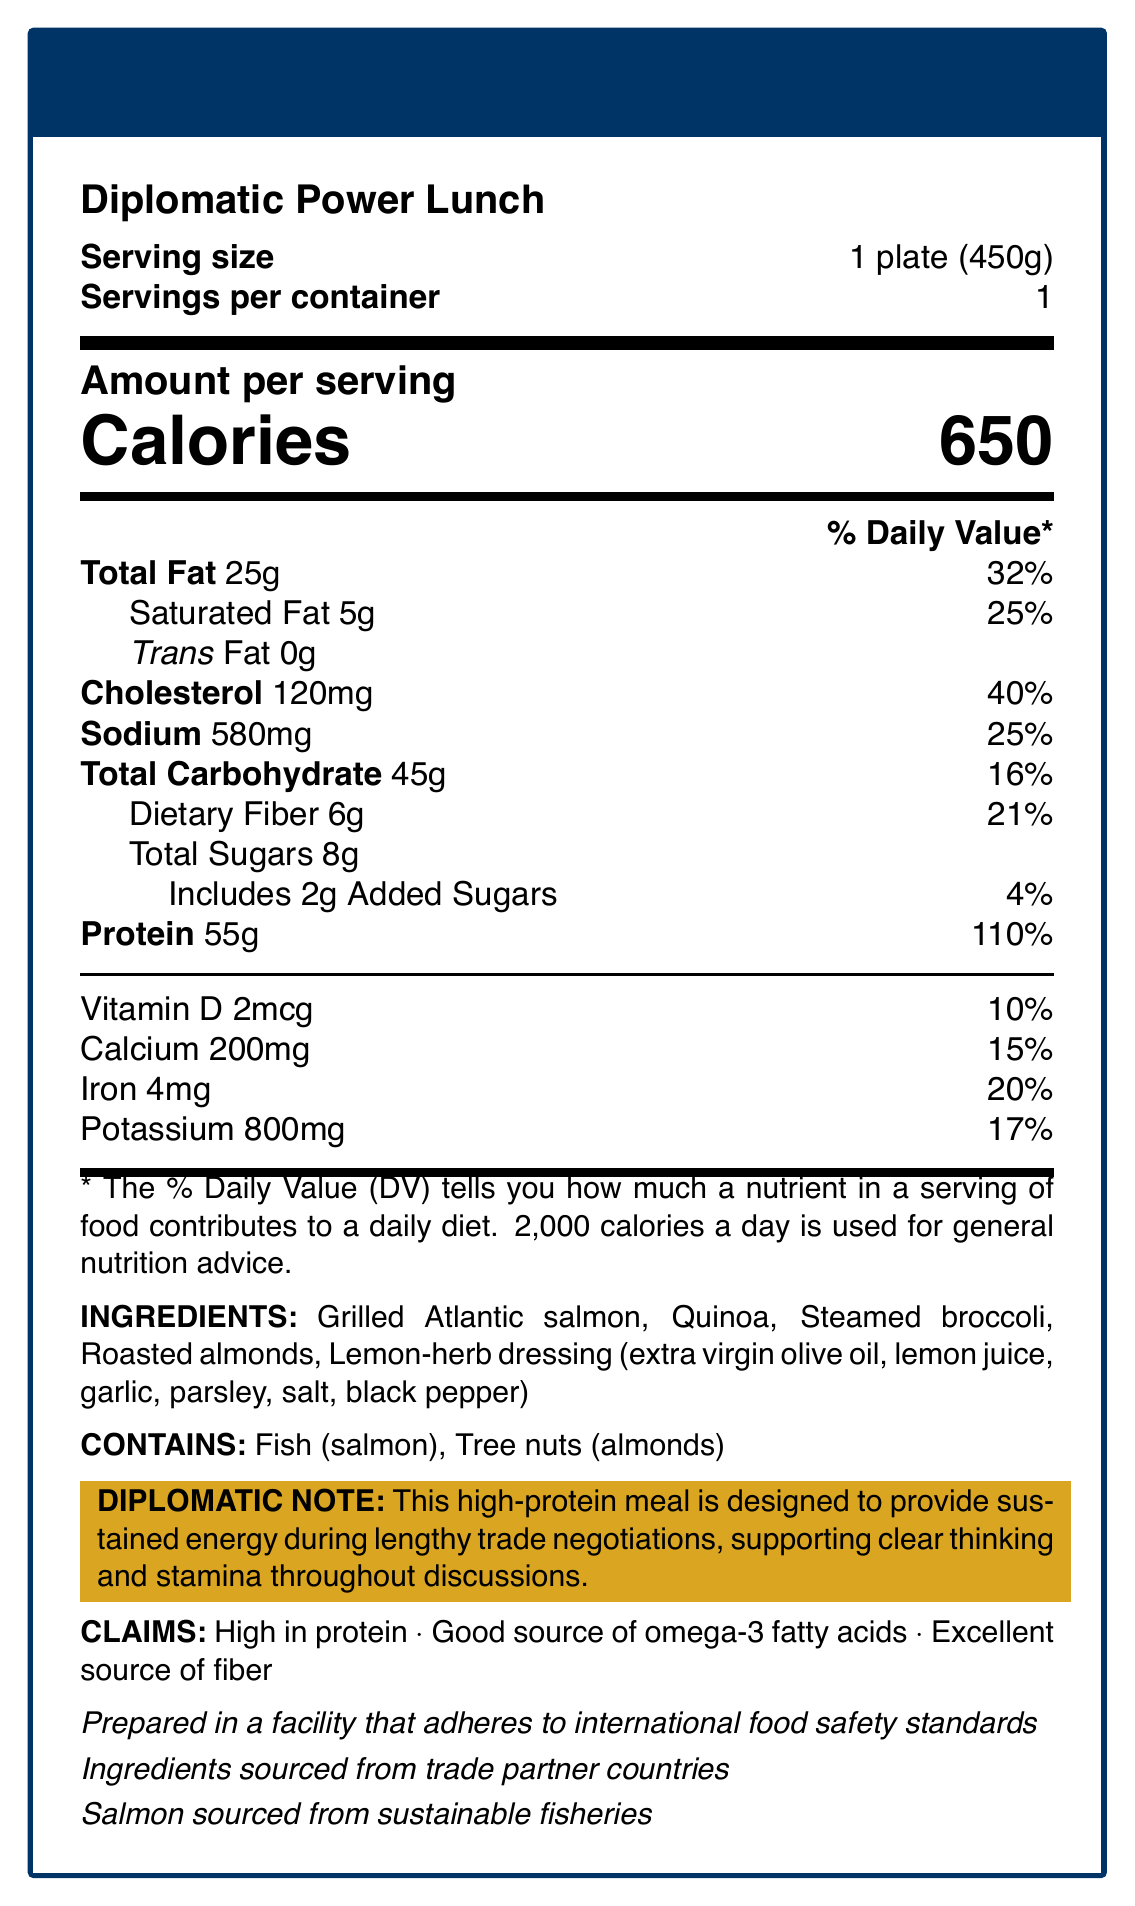what is the serving size for the Diplomatic Power Lunch? The serving size is directly stated in the document as "1 plate (450g)."
Answer: 1 plate (450g) how many calories are in one serving of the Diplomatic Power Lunch? The document clearly indicates that there are 650 calories in one serving.
Answer: 650 what allergens are present in the Diplomatic Power Lunch? The allergens are listed under the "CONTAINS" section as "Fish (salmon)" and "Tree nuts (almonds)."
Answer: Fish (salmon), Tree nuts (almonds) how many grams of protein are in one serving? The protein content is explicitly mentioned as 55 grams per serving in the nutritional facts.
Answer: 55 grams what percentage of daily value is provided by the cholesterol content? Cholesterol provides 40% of the daily value, as listed in the document.
Answer: 40% how much added sugars does the Diplomatic Power Lunch contain? The document states that the Diplomatic Power Lunch includes 2 grams of added sugars.
Answer: 2 grams which ingredient in the meal is a source of omega-3 fatty acids? A. Quinoa B. Steamed broccoli C. Grilled Atlantic salmon D. Roasted almonds According to the claims, "Grilled Atlantic salmon" is a good source of omega-3 fatty acids.
Answer: C what are the three claims made about this meal? A. Low in fat B. Excellent source of fiber C. Contains no added sugars D. High in protein E. Good source of omega-3 fatty acids The claims listed are "High in protein," "Good source of omega-3 fatty acids," and "Excellent source of fiber."
Answer: B, D, E is the Diplomatic Power Lunch prepared with international food safety standards? The document notes that this meal is "Prepared in a facility that adheres to international food safety standards."
Answer: Yes summarize the main purpose of the Diplomatic Power Lunch. The document describes the meal's nutritional information, ingredients, allergen content, and claims, emphasizing its role in diplomatic contexts and its nutritional benefits.
Answer: The Diplomatic Power Lunch is a high-protein meal intended to provide sustained energy during lengthy trade negotiations, supporting clear thinking and stamina. It contains nutrient-rich ingredients sourced sustainably and prepared in compliance with international food safety standards. where are the ingredients for the Diplomatic Power Lunch sourced from? The document states that the ingredients are sourced from trade partner countries.
Answer: Trade partner countries how much dietary fiber does one serving of the Diplomatic Power Lunch contain? The nutritional facts list 6 grams of dietary fiber per serving.
Answer: 6 grams cannot be determined: is the lemon-herb dressing used in the meal organic? The document does not provide any information on whether the lemon-herb dressing is organic.
Answer: Cannot be determined how much vitamin D is present in one serving of the Diplomatic Power Lunch? The document states that there are 2 mcg of vitamin D in one serving.
Answer: 2 mcg how many servings are there in one container of the Diplomatic Power Lunch? The document specifies that there is 1 serving per container.
Answer: 1 